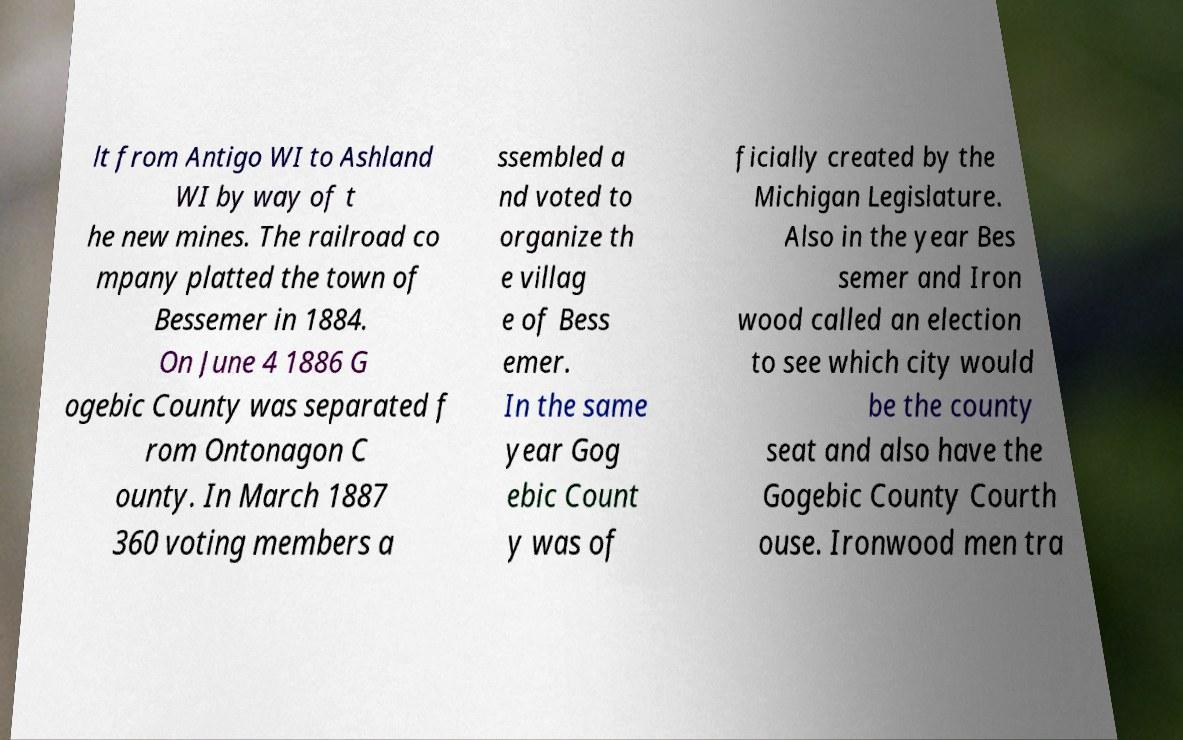There's text embedded in this image that I need extracted. Can you transcribe it verbatim? lt from Antigo WI to Ashland WI by way of t he new mines. The railroad co mpany platted the town of Bessemer in 1884. On June 4 1886 G ogebic County was separated f rom Ontonagon C ounty. In March 1887 360 voting members a ssembled a nd voted to organize th e villag e of Bess emer. In the same year Gog ebic Count y was of ficially created by the Michigan Legislature. Also in the year Bes semer and Iron wood called an election to see which city would be the county seat and also have the Gogebic County Courth ouse. Ironwood men tra 